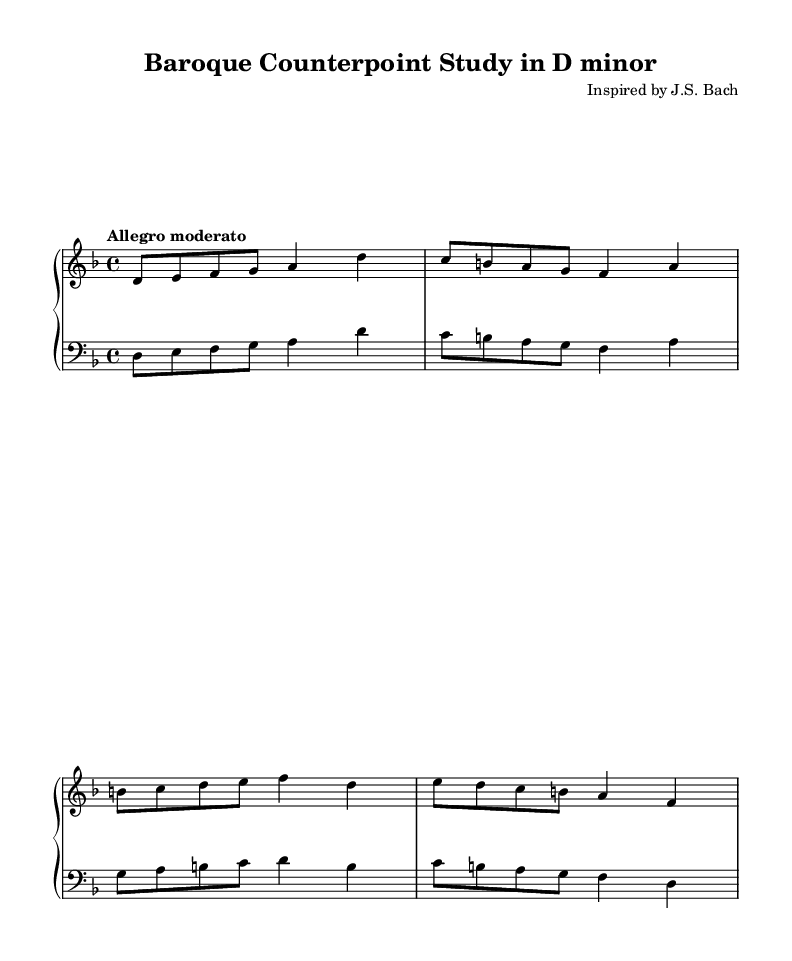What is the key signature of this music? The key signature is indicated by the number of sharps or flats at the beginning of the staff. In this case, it is D minor, which has one flat (B flat).
Answer: D minor What is the time signature of this music? The time signature is shown at the beginning of the staff, represented by two numbers; the top number indicates the number of beats per measure (4), and the bottom number indicates the note value that gets one beat (4 corresponds to a quarter note).
Answer: 4/4 What is the tempo marking for this piece? The tempo is marked above the staff with the term "Allegro moderato," which indicates a moderately fast tempo.
Answer: Allegro moderato How many measures are in the right hand part? By counting the groups of notes separated by vertical lines (bar lines), there are a total of four measures in the right hand part.
Answer: 4 How does the left hand relate to the right hand in this composition? The left hand plays notes that harmonically support the right hand's melody, often incorporating similar rhythmic patterns and complementary note selections, which is typical of counterpoint technique.
Answer: Counterpoint What is the primary compositional technique showcased in this piece? This composition prominently features counterpoint, which is the art of combining different melodic lines to create harmony and complexity.
Answer: Counterpoint What is the general mood conveyed by the music? The tempo marking "Allegro moderato" suggests a lively yet controlled character, typical of Baroque compositions that often evoke feelings of joy and energy while maintaining elegance.
Answer: Lively 